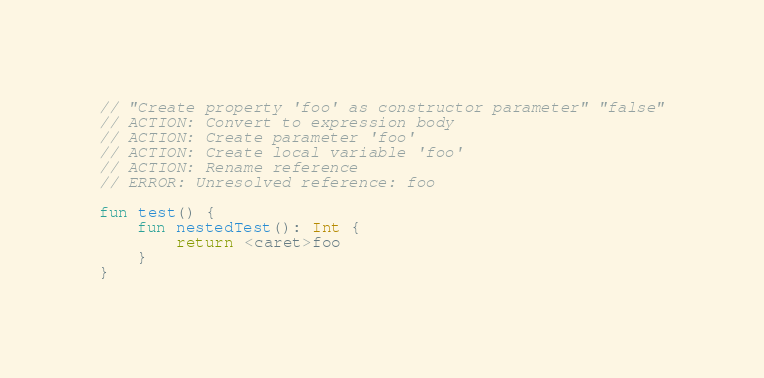Convert code to text. <code><loc_0><loc_0><loc_500><loc_500><_Kotlin_>// "Create property 'foo' as constructor parameter" "false"
// ACTION: Convert to expression body
// ACTION: Create parameter 'foo'
// ACTION: Create local variable 'foo'
// ACTION: Rename reference
// ERROR: Unresolved reference: foo

fun test() {
    fun nestedTest(): Int {
        return <caret>foo
    }
}
</code> 